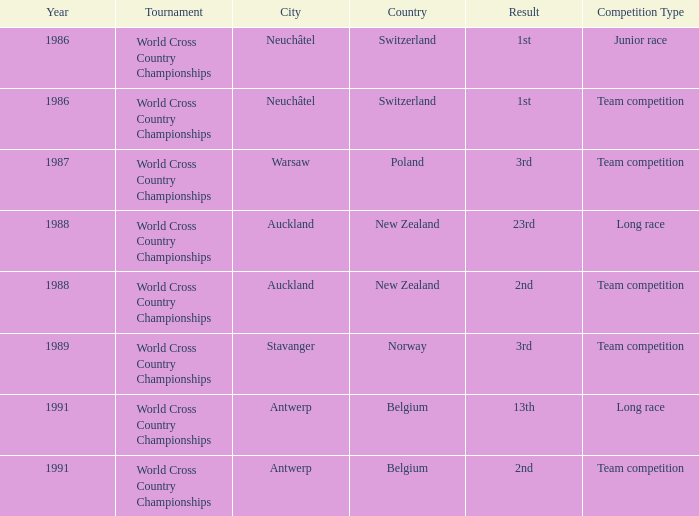Which venue led to a result of 13th and had an extra of Long Race? Antwerp , Belgium. 